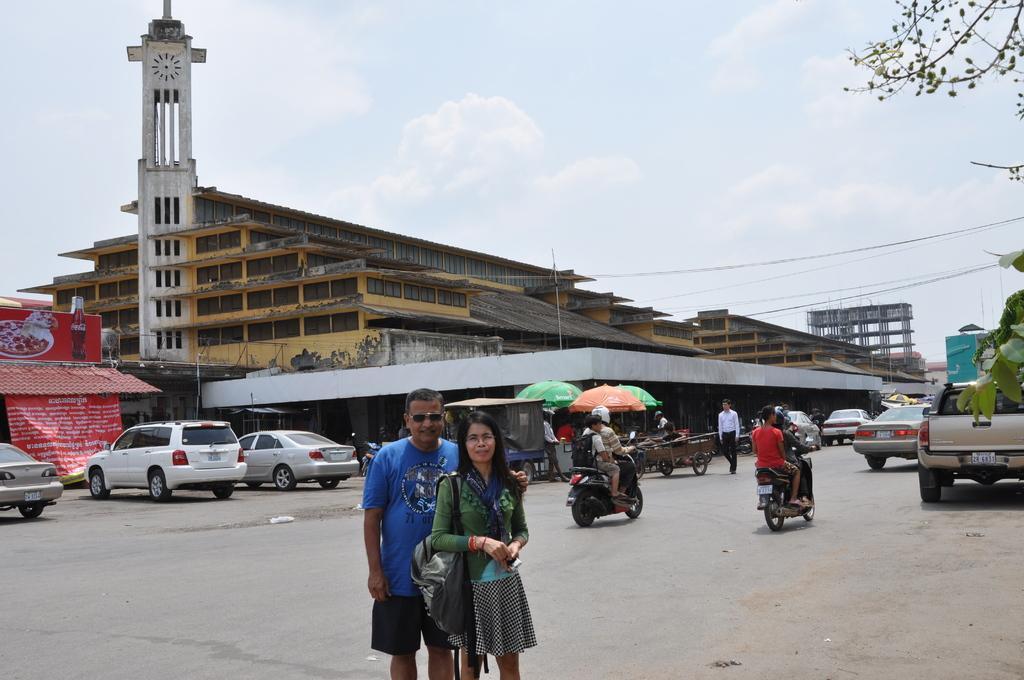Can you describe this image briefly? In this picture I can see the couple who is standing on the road. On the right I can see the group of persons who are riding the bikes. Beside them we can see cars and other vehicle. In the back I can see the buildings, shed and vehicles. On the left I can see the banner and posters which is placed on the wall. At the top I can see the sky and clouds. In the top right I can see the electric wires and trees. 